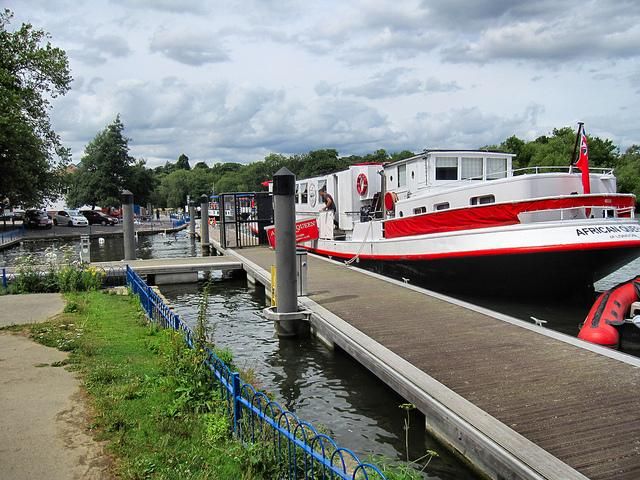What's the term for how this boat is parked? docked 